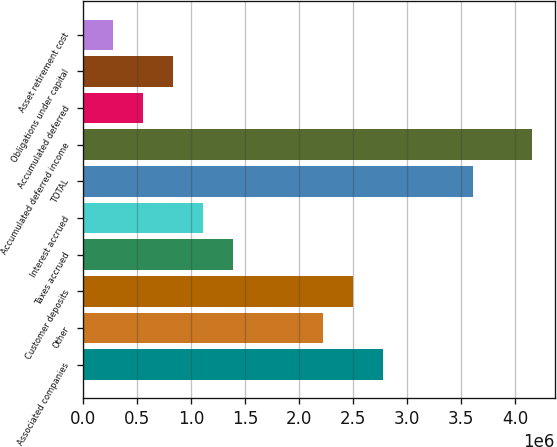<chart> <loc_0><loc_0><loc_500><loc_500><bar_chart><fcel>Associated companies<fcel>Other<fcel>Customer deposits<fcel>Taxes accrued<fcel>Interest accrued<fcel>TOTAL<fcel>Accumulated deferred income<fcel>Accumulated deferred<fcel>Obligations under capital<fcel>Asset retirement cost<nl><fcel>2.77278e+06<fcel>2.21836e+06<fcel>2.49557e+06<fcel>1.38673e+06<fcel>1.10953e+06<fcel>3.6044e+06<fcel>4.15882e+06<fcel>555108<fcel>832316<fcel>277899<nl></chart> 